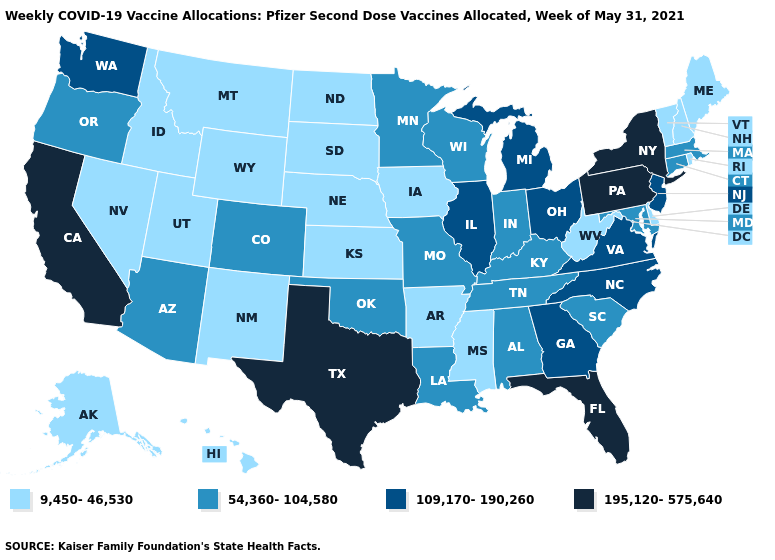What is the highest value in states that border Maryland?
Give a very brief answer. 195,120-575,640. What is the value of Idaho?
Short answer required. 9,450-46,530. Does Idaho have the lowest value in the USA?
Concise answer only. Yes. Name the states that have a value in the range 9,450-46,530?
Write a very short answer. Alaska, Arkansas, Delaware, Hawaii, Idaho, Iowa, Kansas, Maine, Mississippi, Montana, Nebraska, Nevada, New Hampshire, New Mexico, North Dakota, Rhode Island, South Dakota, Utah, Vermont, West Virginia, Wyoming. Name the states that have a value in the range 195,120-575,640?
Answer briefly. California, Florida, New York, Pennsylvania, Texas. Does Oklahoma have a higher value than Tennessee?
Be succinct. No. Does Pennsylvania have the lowest value in the USA?
Quick response, please. No. Name the states that have a value in the range 9,450-46,530?
Answer briefly. Alaska, Arkansas, Delaware, Hawaii, Idaho, Iowa, Kansas, Maine, Mississippi, Montana, Nebraska, Nevada, New Hampshire, New Mexico, North Dakota, Rhode Island, South Dakota, Utah, Vermont, West Virginia, Wyoming. Does Delaware have the same value as Washington?
Keep it brief. No. What is the lowest value in the USA?
Write a very short answer. 9,450-46,530. What is the value of Georgia?
Give a very brief answer. 109,170-190,260. Does Colorado have a lower value than Massachusetts?
Be succinct. No. What is the value of Kansas?
Be succinct. 9,450-46,530. Which states have the lowest value in the USA?
Give a very brief answer. Alaska, Arkansas, Delaware, Hawaii, Idaho, Iowa, Kansas, Maine, Mississippi, Montana, Nebraska, Nevada, New Hampshire, New Mexico, North Dakota, Rhode Island, South Dakota, Utah, Vermont, West Virginia, Wyoming. What is the value of Montana?
Short answer required. 9,450-46,530. 